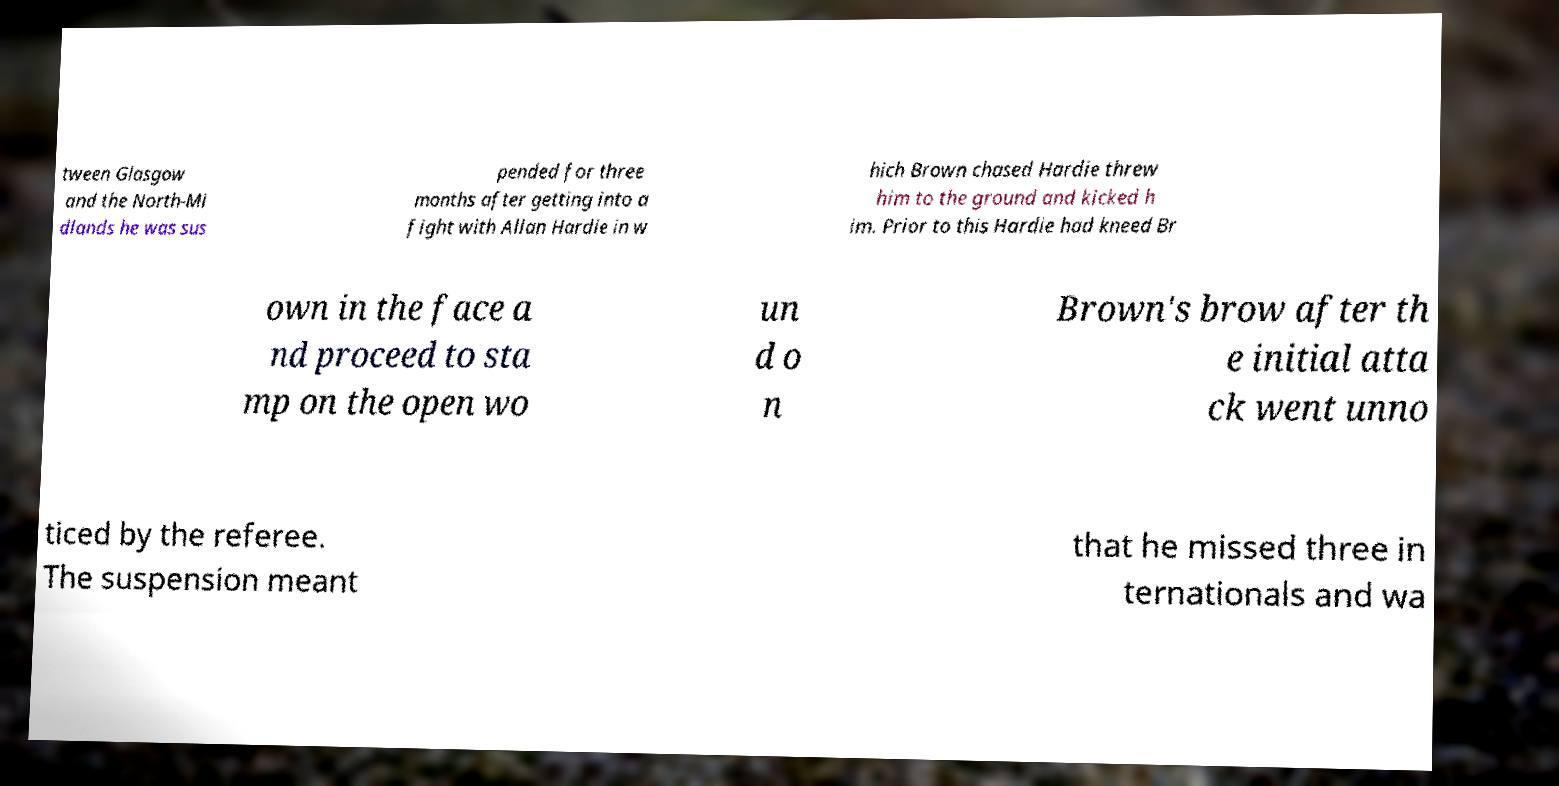Can you accurately transcribe the text from the provided image for me? tween Glasgow and the North-Mi dlands he was sus pended for three months after getting into a fight with Allan Hardie in w hich Brown chased Hardie threw him to the ground and kicked h im. Prior to this Hardie had kneed Br own in the face a nd proceed to sta mp on the open wo un d o n Brown's brow after th e initial atta ck went unno ticed by the referee. The suspension meant that he missed three in ternationals and wa 